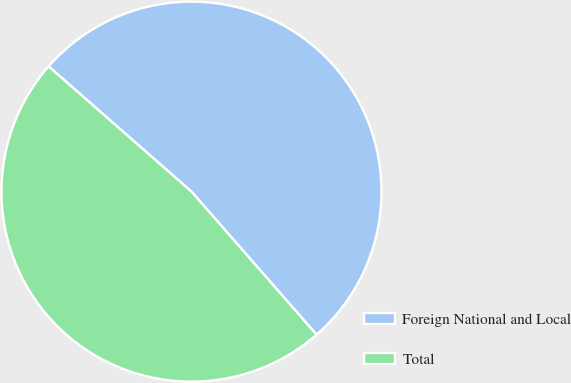<chart> <loc_0><loc_0><loc_500><loc_500><pie_chart><fcel>Foreign National and Local<fcel>Total<nl><fcel>52.11%<fcel>47.89%<nl></chart> 